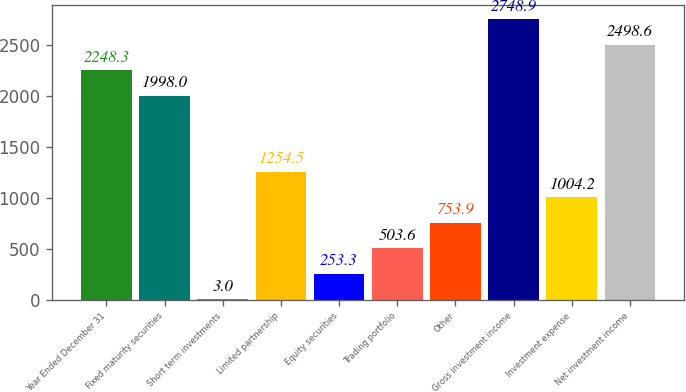<chart> <loc_0><loc_0><loc_500><loc_500><bar_chart><fcel>Year Ended December 31<fcel>Fixed maturity securities<fcel>Short term investments<fcel>Limited partnership<fcel>Equity securities<fcel>Trading portfolio<fcel>Other<fcel>Gross investment income<fcel>Investment expense<fcel>Net investment income<nl><fcel>2248.3<fcel>1998<fcel>3<fcel>1254.5<fcel>253.3<fcel>503.6<fcel>753.9<fcel>2748.9<fcel>1004.2<fcel>2498.6<nl></chart> 